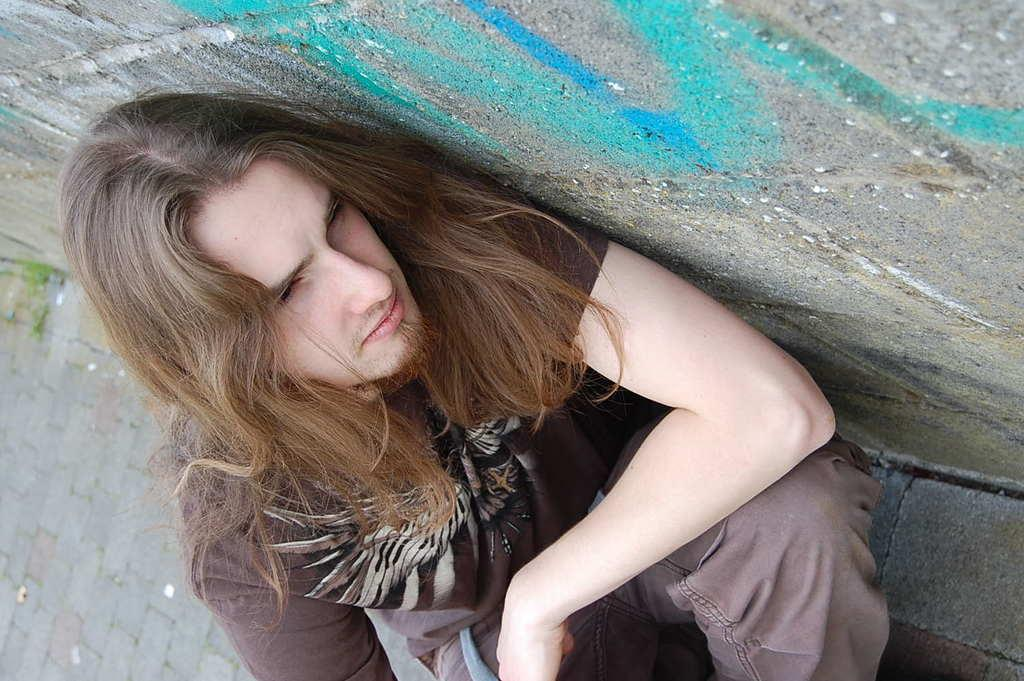Who or what is the main subject in the image? There is a person in the image. Can you describe the person's appearance? The person has long hair. What is located beside the person in the image? There is a wall beside the person in the image. How many pies are hanging from the rail in the image? There is no rail or pies present in the image. What type of icicle can be seen melting on the person's hair in the image? There is no icicle present in the image; the person has long hair, but it is not mentioned to be frozen or melting. 